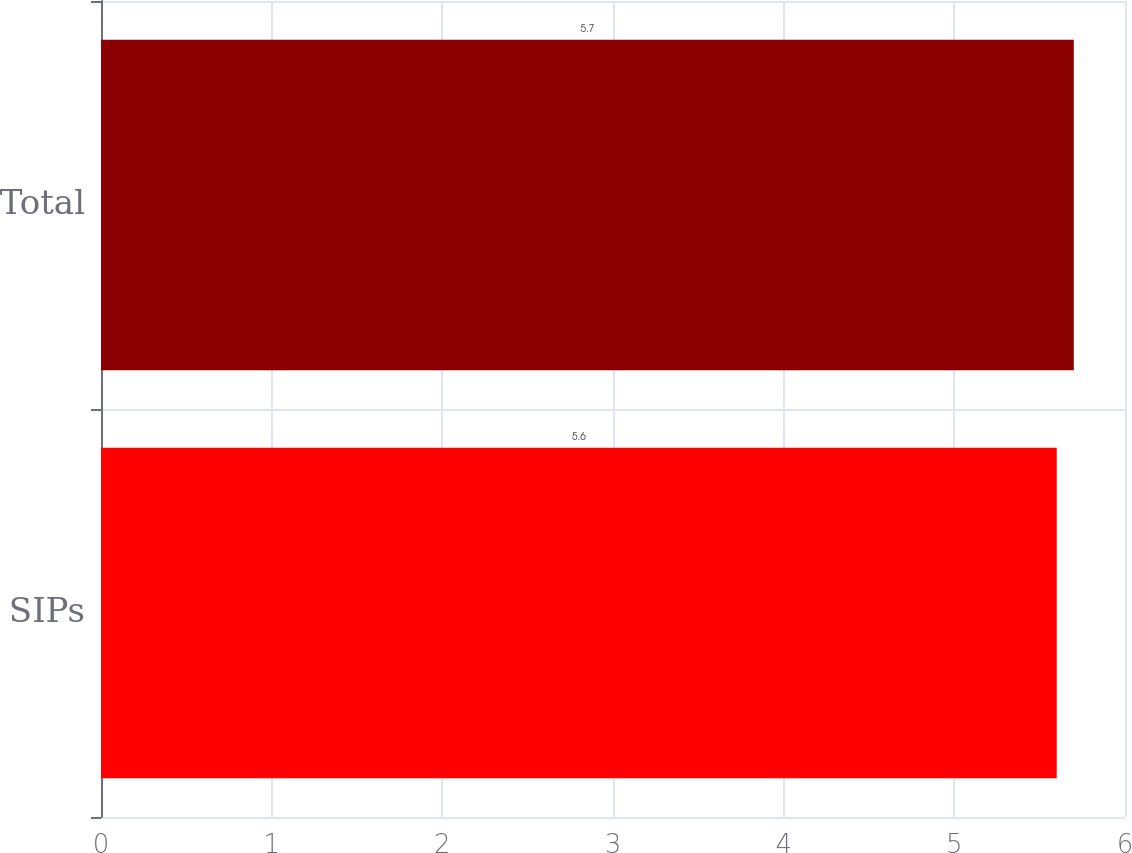Convert chart to OTSL. <chart><loc_0><loc_0><loc_500><loc_500><bar_chart><fcel>SIPs<fcel>Total<nl><fcel>5.6<fcel>5.7<nl></chart> 